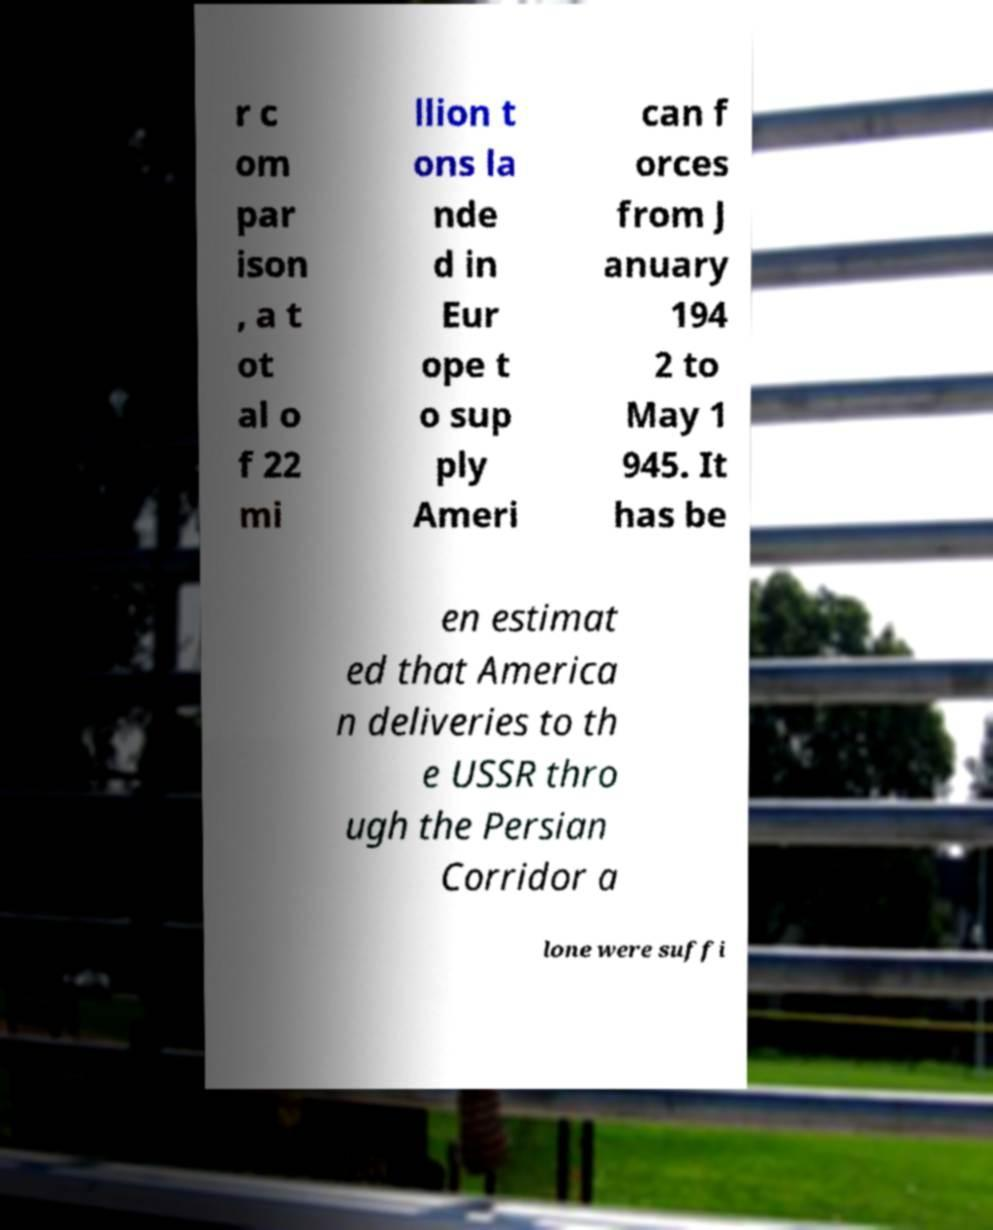There's text embedded in this image that I need extracted. Can you transcribe it verbatim? r c om par ison , a t ot al o f 22 mi llion t ons la nde d in Eur ope t o sup ply Ameri can f orces from J anuary 194 2 to May 1 945. It has be en estimat ed that America n deliveries to th e USSR thro ugh the Persian Corridor a lone were suffi 